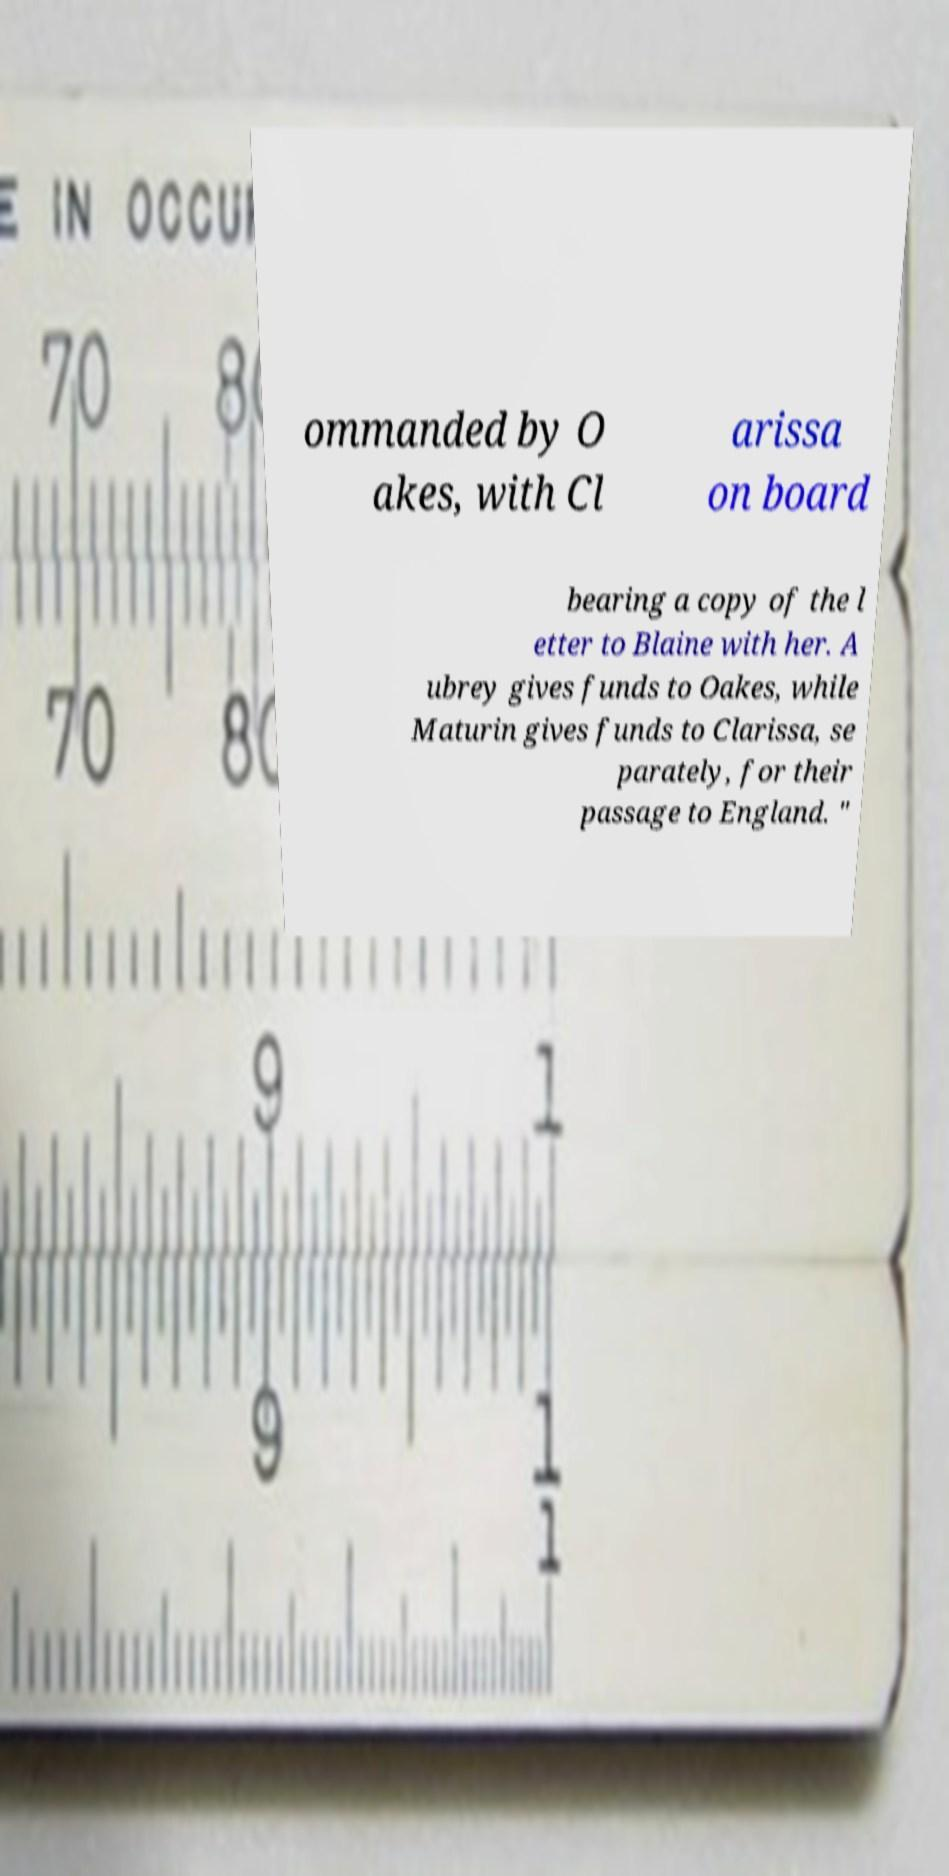Please read and relay the text visible in this image. What does it say? ommanded by O akes, with Cl arissa on board bearing a copy of the l etter to Blaine with her. A ubrey gives funds to Oakes, while Maturin gives funds to Clarissa, se parately, for their passage to England. " 